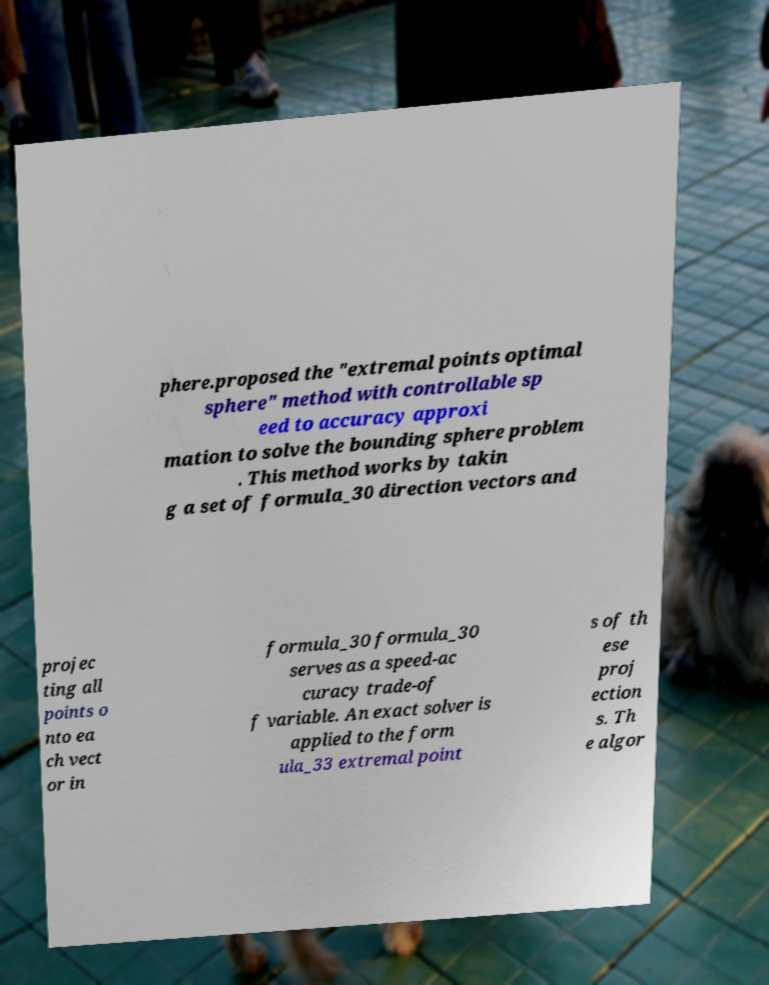Please read and relay the text visible in this image. What does it say? phere.proposed the "extremal points optimal sphere" method with controllable sp eed to accuracy approxi mation to solve the bounding sphere problem . This method works by takin g a set of formula_30 direction vectors and projec ting all points o nto ea ch vect or in formula_30 formula_30 serves as a speed-ac curacy trade-of f variable. An exact solver is applied to the form ula_33 extremal point s of th ese proj ection s. Th e algor 